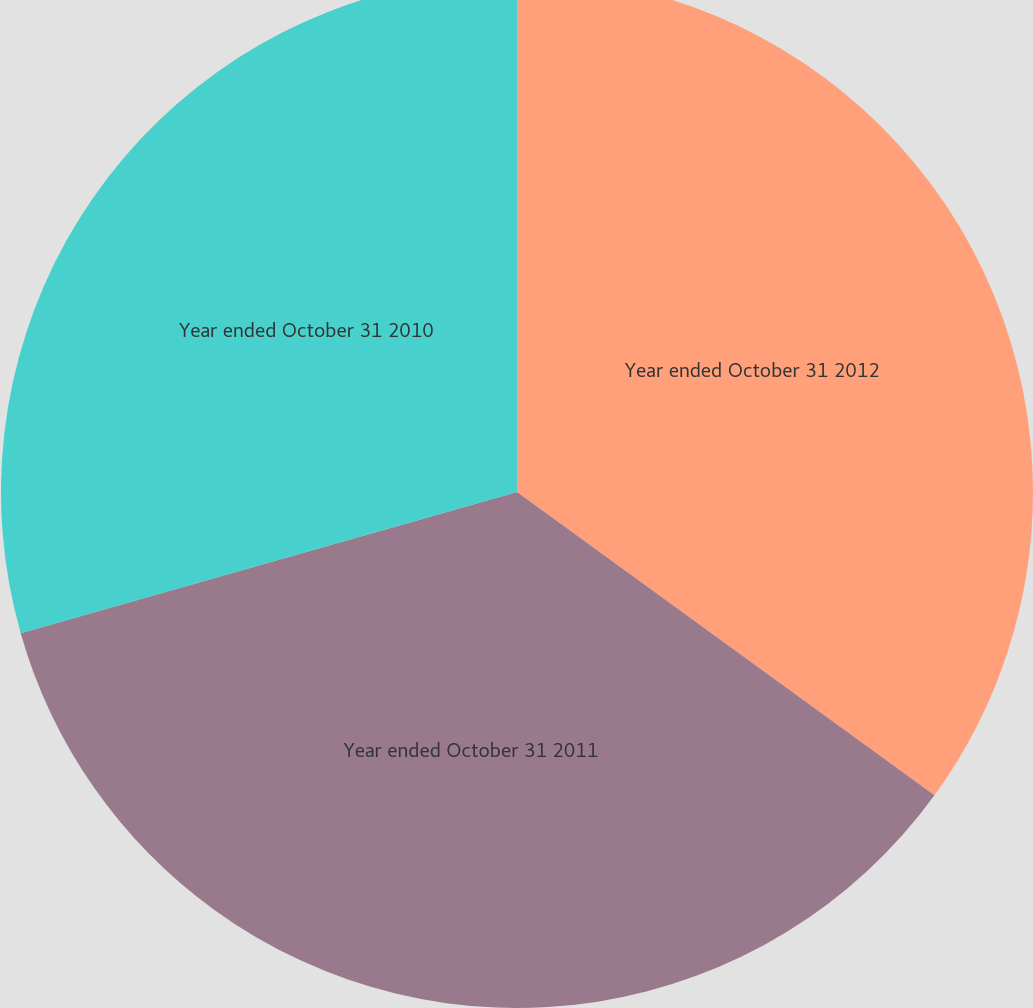Convert chart to OTSL. <chart><loc_0><loc_0><loc_500><loc_500><pie_chart><fcel>Year ended October 31 2012<fcel>Year ended October 31 2011<fcel>Year ended October 31 2010<nl><fcel>35.0%<fcel>35.59%<fcel>29.41%<nl></chart> 